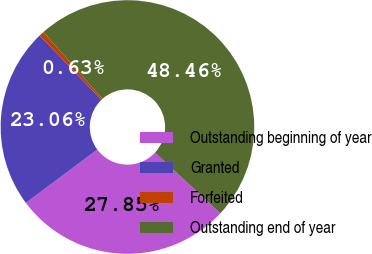<chart> <loc_0><loc_0><loc_500><loc_500><pie_chart><fcel>Outstanding beginning of year<fcel>Granted<fcel>Forfeited<fcel>Outstanding end of year<nl><fcel>27.85%<fcel>23.06%<fcel>0.63%<fcel>48.46%<nl></chart> 